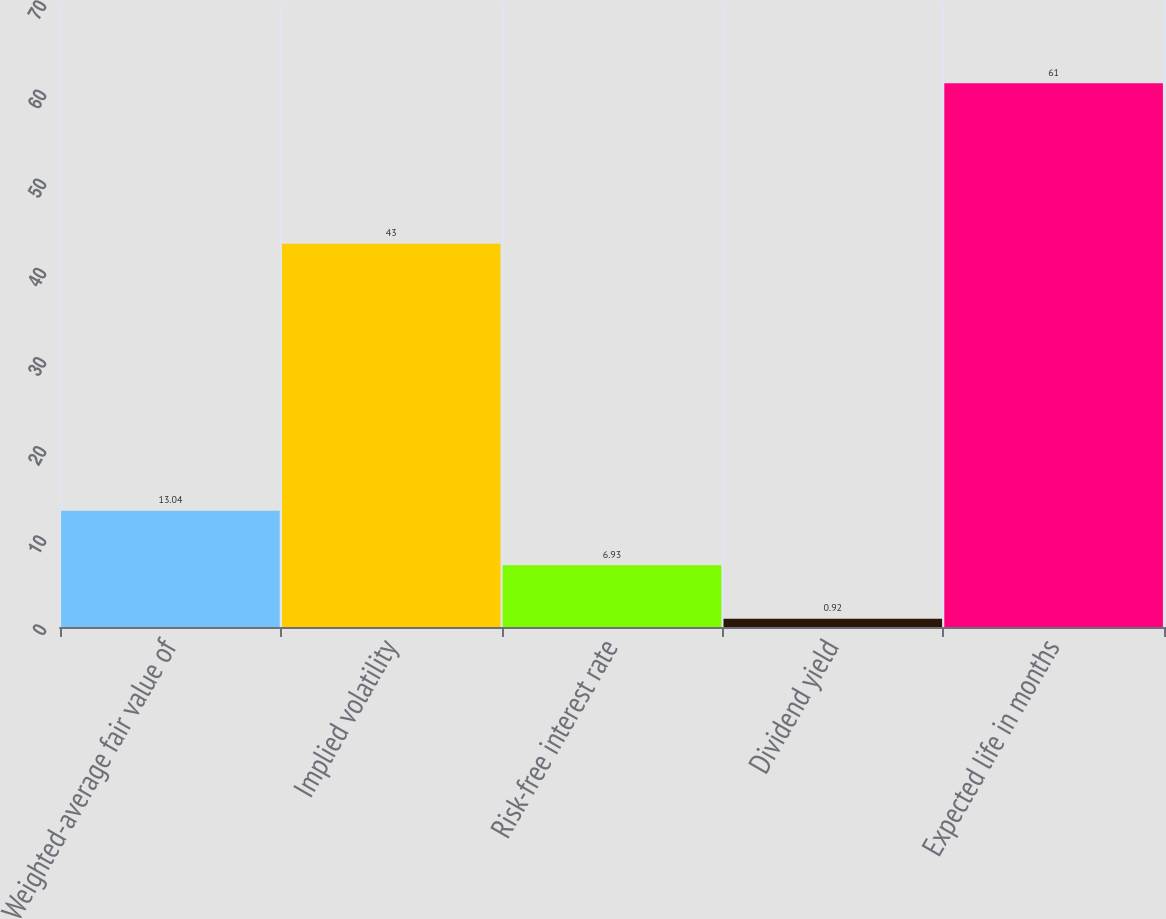<chart> <loc_0><loc_0><loc_500><loc_500><bar_chart><fcel>Weighted-average fair value of<fcel>Implied volatility<fcel>Risk-free interest rate<fcel>Dividend yield<fcel>Expected life in months<nl><fcel>13.04<fcel>43<fcel>6.93<fcel>0.92<fcel>61<nl></chart> 